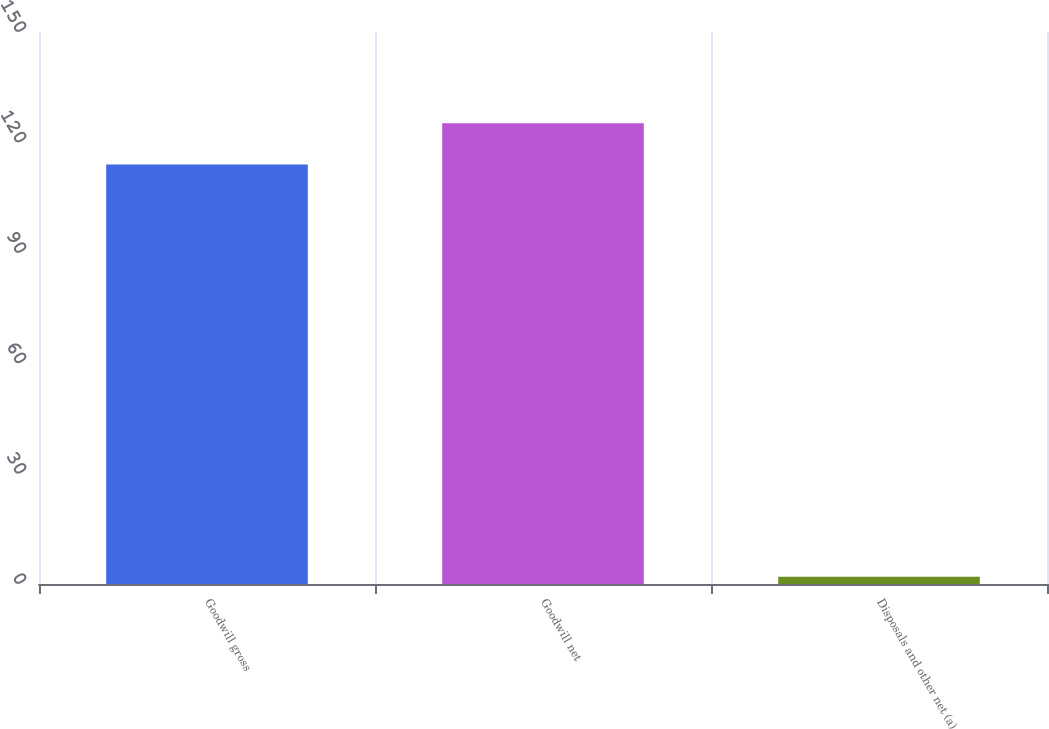Convert chart to OTSL. <chart><loc_0><loc_0><loc_500><loc_500><bar_chart><fcel>Goodwill gross<fcel>Goodwill net<fcel>Disposals and other net (a)<nl><fcel>114<fcel>125.2<fcel>2<nl></chart> 